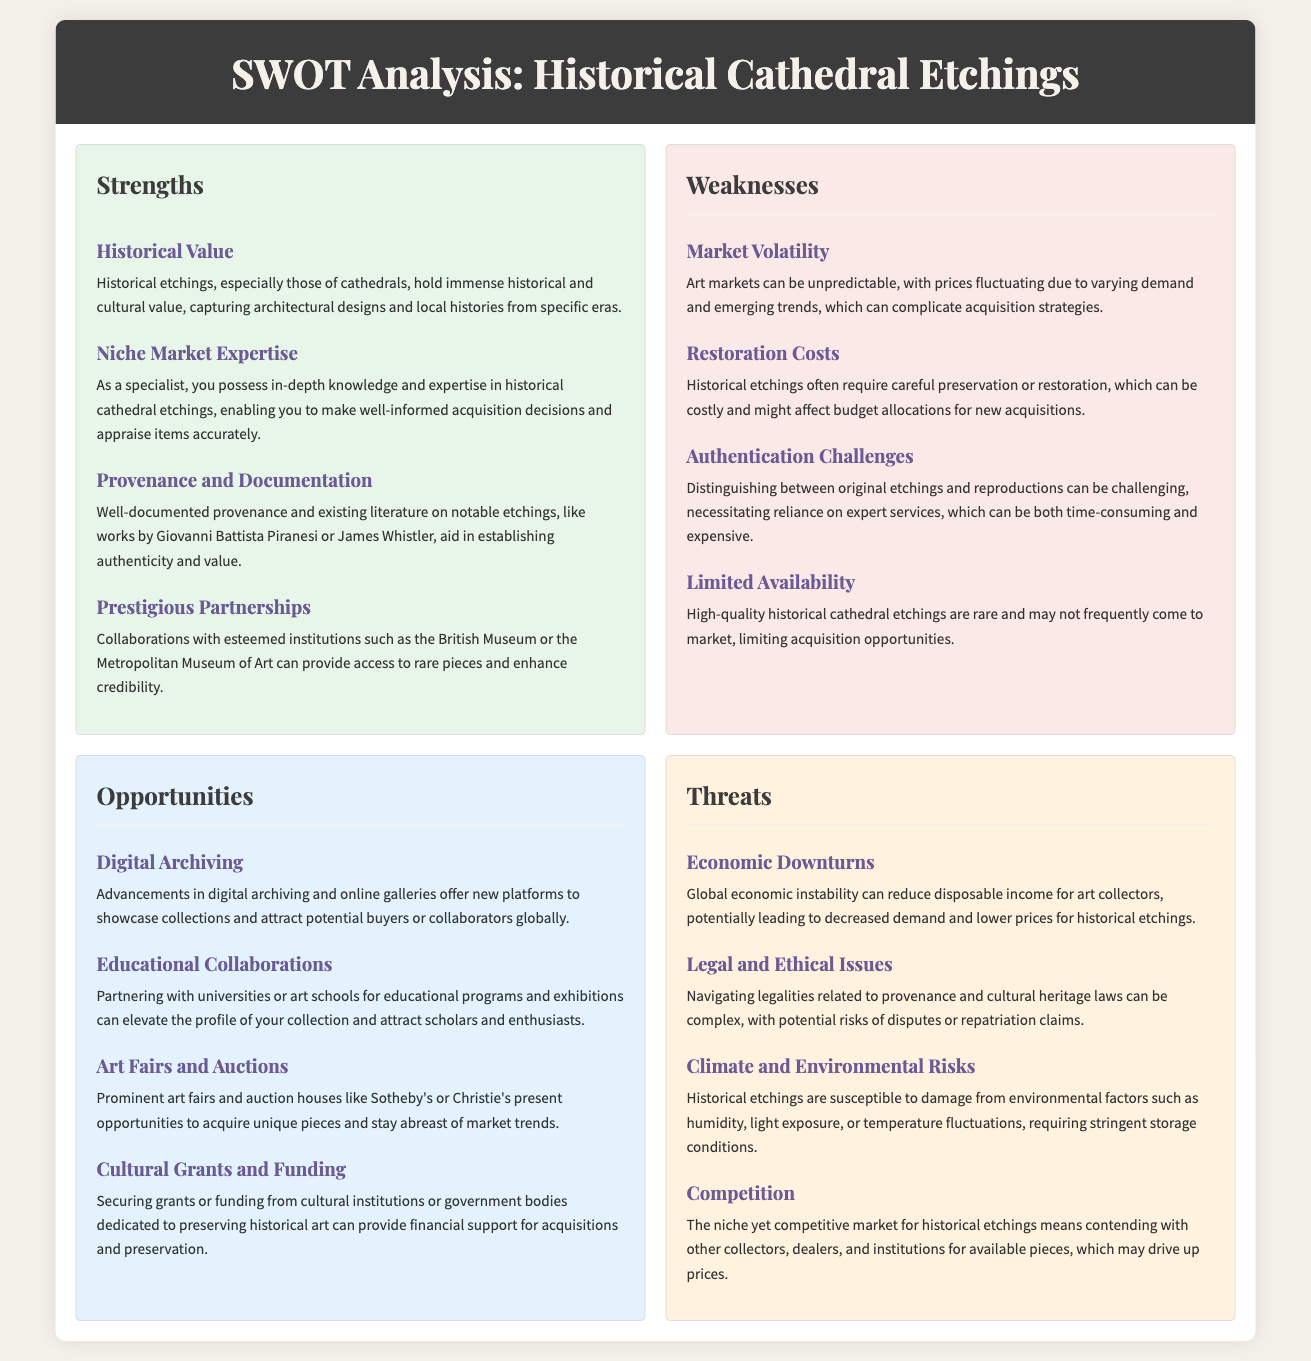What is the significance of historical etchings in the market? Historical etchings, especially those of cathedrals, hold immense historical and cultural value, capturing architectural designs and local histories from specific eras.
Answer: Immense historical and cultural value What is a weakness related to the costs of preserving historical etchings? Historical etchings often require careful preservation or restoration, which can be costly and might affect budget allocations for new acquisitions.
Answer: Restoration costs Which opportunity involves new platforms for display? Advancements in digital archiving and online galleries offer new platforms to showcase collections and attract potential buyers or collaborators globally.
Answer: Digital archiving What is a threat posed by environmental factors? Historical etchings are susceptible to damage from environmental factors such as humidity, light exposure, or temperature fluctuations, requiring stringent storage conditions.
Answer: Climate and environmental risks What can help establish the authenticity of cathedral etchings? Well-documented provenance and existing literature on notable etchings aid in establishing authenticity and value.
Answer: Provenance and documentation Which opportunity involves partnering with educational institutions? Partnering with universities or art schools for educational programs can elevate the profile of your collection and attract scholars and enthusiasts.
Answer: Educational collaborations What economic situation could reduce the demand for art collecting? Global economic instability can reduce disposable income for art collectors, potentially leading to decreased demand and lower prices for historical etchings.
Answer: Economic downturns 